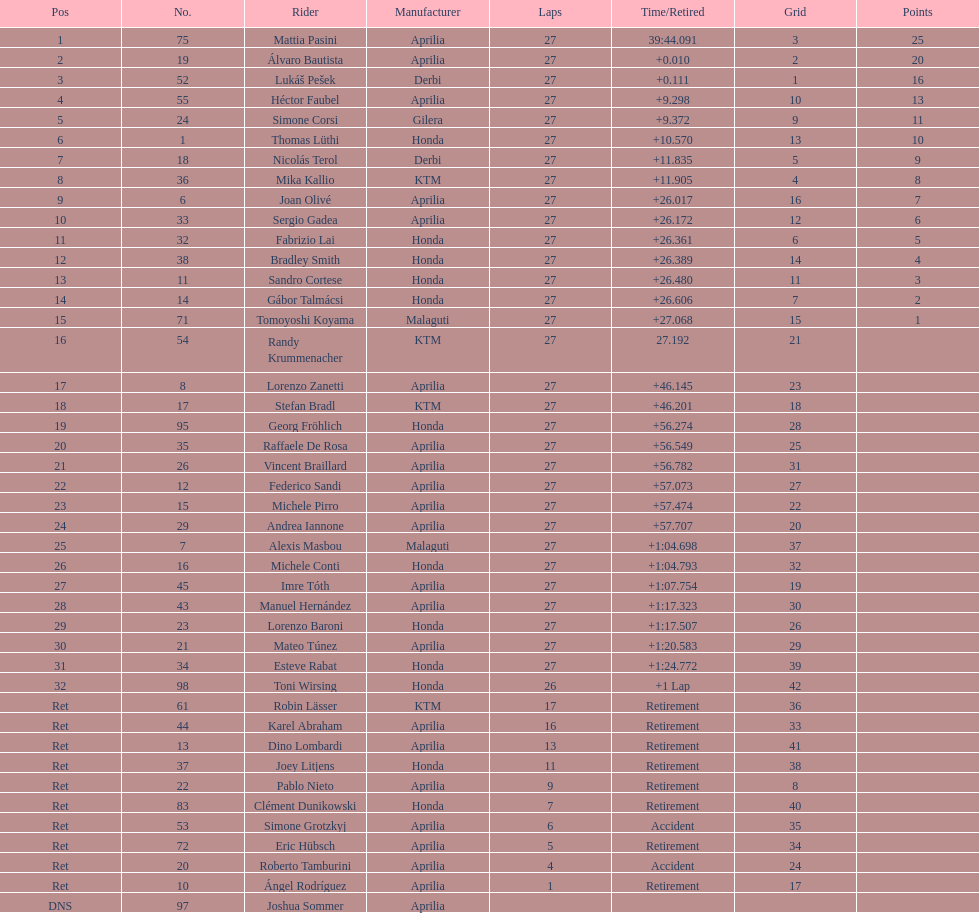Which rider came in first with 25 points? Mattia Pasini. 